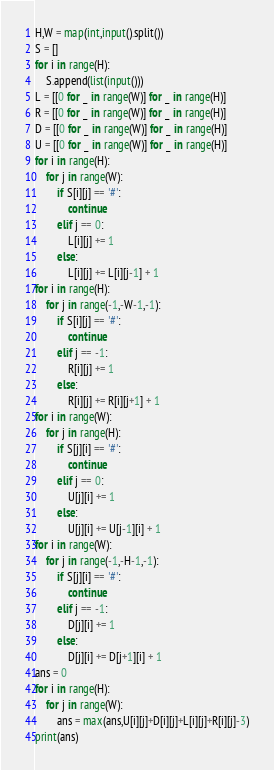<code> <loc_0><loc_0><loc_500><loc_500><_Python_>H,W = map(int,input().split())
S = []
for i in range(H):
    S.append(list(input()))
L = [[0 for _ in range(W)] for _ in range(H)]
R = [[0 for _ in range(W)] for _ in range(H)]
D = [[0 for _ in range(W)] for _ in range(H)]
U = [[0 for _ in range(W)] for _ in range(H)]
for i in range(H):
    for j in range(W):
        if S[i][j] == '#':
            continue
        elif j == 0:
            L[i][j] += 1
        else:
            L[i][j] += L[i][j-1] + 1
for i in range(H):
    for j in range(-1,-W-1,-1):
        if S[i][j] == '#':
            continue
        elif j == -1:
            R[i][j] += 1
        else:
            R[i][j] += R[i][j+1] + 1
for i in range(W):
    for j in range(H):
        if S[j][i] == '#':
            continue
        elif j == 0:
            U[j][i] += 1
        else:
            U[j][i] += U[j-1][i] + 1
for i in range(W):
    for j in range(-1,-H-1,-1):
        if S[j][i] == '#':
            continue
        elif j == -1:
            D[j][i] += 1
        else:
            D[j][i] += D[j+1][i] + 1
ans = 0
for i in range(H):
    for j in range(W):
        ans = max(ans,U[i][j]+D[i][j]+L[i][j]+R[i][j]-3)
print(ans)</code> 